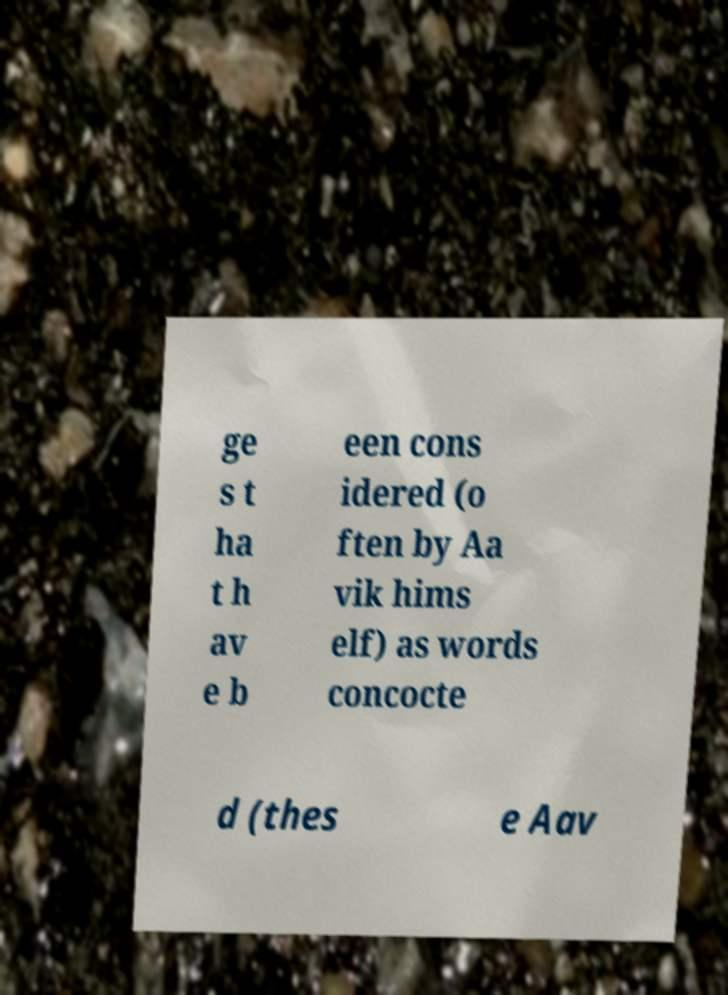Could you extract and type out the text from this image? ge s t ha t h av e b een cons idered (o ften by Aa vik hims elf) as words concocte d (thes e Aav 